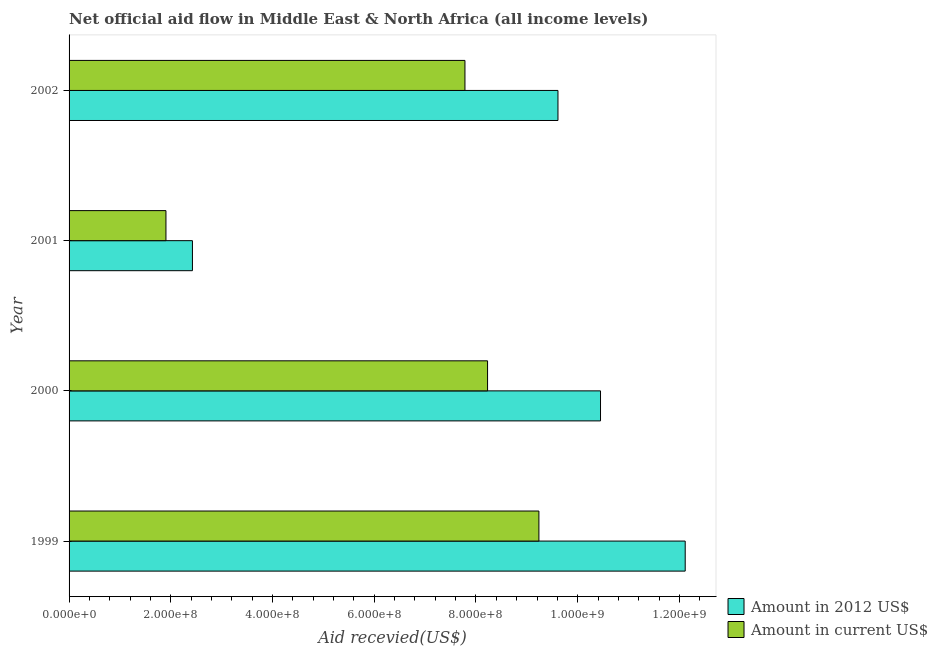Are the number of bars per tick equal to the number of legend labels?
Give a very brief answer. Yes. Are the number of bars on each tick of the Y-axis equal?
Provide a short and direct response. Yes. How many bars are there on the 2nd tick from the bottom?
Your response must be concise. 2. What is the label of the 4th group of bars from the top?
Provide a short and direct response. 1999. What is the amount of aid received(expressed in us$) in 2000?
Your response must be concise. 8.23e+08. Across all years, what is the maximum amount of aid received(expressed in 2012 us$)?
Make the answer very short. 1.21e+09. Across all years, what is the minimum amount of aid received(expressed in 2012 us$)?
Your answer should be compact. 2.43e+08. In which year was the amount of aid received(expressed in 2012 us$) minimum?
Keep it short and to the point. 2001. What is the total amount of aid received(expressed in us$) in the graph?
Your response must be concise. 2.72e+09. What is the difference between the amount of aid received(expressed in 2012 us$) in 1999 and that in 2001?
Ensure brevity in your answer.  9.69e+08. What is the difference between the amount of aid received(expressed in 2012 us$) in 2000 and the amount of aid received(expressed in us$) in 1999?
Your answer should be compact. 1.21e+08. What is the average amount of aid received(expressed in 2012 us$) per year?
Make the answer very short. 8.65e+08. In the year 2001, what is the difference between the amount of aid received(expressed in 2012 us$) and amount of aid received(expressed in us$)?
Offer a terse response. 5.21e+07. What is the ratio of the amount of aid received(expressed in us$) in 1999 to that in 2001?
Offer a very short reply. 4.85. Is the difference between the amount of aid received(expressed in us$) in 2000 and 2002 greater than the difference between the amount of aid received(expressed in 2012 us$) in 2000 and 2002?
Keep it short and to the point. No. What is the difference between the highest and the second highest amount of aid received(expressed in us$)?
Provide a short and direct response. 1.01e+08. What is the difference between the highest and the lowest amount of aid received(expressed in 2012 us$)?
Give a very brief answer. 9.69e+08. In how many years, is the amount of aid received(expressed in us$) greater than the average amount of aid received(expressed in us$) taken over all years?
Your response must be concise. 3. Is the sum of the amount of aid received(expressed in 2012 us$) in 1999 and 2000 greater than the maximum amount of aid received(expressed in us$) across all years?
Provide a succinct answer. Yes. What does the 2nd bar from the top in 2001 represents?
Give a very brief answer. Amount in 2012 US$. What does the 2nd bar from the bottom in 1999 represents?
Give a very brief answer. Amount in current US$. Are all the bars in the graph horizontal?
Offer a very short reply. Yes. How many years are there in the graph?
Your answer should be compact. 4. Does the graph contain grids?
Offer a terse response. No. Where does the legend appear in the graph?
Give a very brief answer. Bottom right. How many legend labels are there?
Offer a very short reply. 2. What is the title of the graph?
Give a very brief answer. Net official aid flow in Middle East & North Africa (all income levels). What is the label or title of the X-axis?
Your response must be concise. Aid recevied(US$). What is the label or title of the Y-axis?
Ensure brevity in your answer.  Year. What is the Aid recevied(US$) of Amount in 2012 US$ in 1999?
Your answer should be very brief. 1.21e+09. What is the Aid recevied(US$) of Amount in current US$ in 1999?
Make the answer very short. 9.24e+08. What is the Aid recevied(US$) of Amount in 2012 US$ in 2000?
Provide a short and direct response. 1.04e+09. What is the Aid recevied(US$) in Amount in current US$ in 2000?
Your response must be concise. 8.23e+08. What is the Aid recevied(US$) in Amount in 2012 US$ in 2001?
Offer a very short reply. 2.43e+08. What is the Aid recevied(US$) of Amount in current US$ in 2001?
Your answer should be compact. 1.90e+08. What is the Aid recevied(US$) in Amount in 2012 US$ in 2002?
Ensure brevity in your answer.  9.61e+08. What is the Aid recevied(US$) of Amount in current US$ in 2002?
Offer a terse response. 7.78e+08. Across all years, what is the maximum Aid recevied(US$) in Amount in 2012 US$?
Offer a terse response. 1.21e+09. Across all years, what is the maximum Aid recevied(US$) of Amount in current US$?
Your answer should be compact. 9.24e+08. Across all years, what is the minimum Aid recevied(US$) in Amount in 2012 US$?
Ensure brevity in your answer.  2.43e+08. Across all years, what is the minimum Aid recevied(US$) of Amount in current US$?
Provide a succinct answer. 1.90e+08. What is the total Aid recevied(US$) in Amount in 2012 US$ in the graph?
Ensure brevity in your answer.  3.46e+09. What is the total Aid recevied(US$) of Amount in current US$ in the graph?
Offer a terse response. 2.72e+09. What is the difference between the Aid recevied(US$) in Amount in 2012 US$ in 1999 and that in 2000?
Offer a very short reply. 1.67e+08. What is the difference between the Aid recevied(US$) of Amount in current US$ in 1999 and that in 2000?
Offer a terse response. 1.01e+08. What is the difference between the Aid recevied(US$) in Amount in 2012 US$ in 1999 and that in 2001?
Make the answer very short. 9.69e+08. What is the difference between the Aid recevied(US$) in Amount in current US$ in 1999 and that in 2001?
Ensure brevity in your answer.  7.33e+08. What is the difference between the Aid recevied(US$) in Amount in 2012 US$ in 1999 and that in 2002?
Provide a short and direct response. 2.50e+08. What is the difference between the Aid recevied(US$) in Amount in current US$ in 1999 and that in 2002?
Provide a succinct answer. 1.45e+08. What is the difference between the Aid recevied(US$) in Amount in 2012 US$ in 2000 and that in 2001?
Your answer should be compact. 8.02e+08. What is the difference between the Aid recevied(US$) in Amount in current US$ in 2000 and that in 2001?
Ensure brevity in your answer.  6.32e+08. What is the difference between the Aid recevied(US$) in Amount in 2012 US$ in 2000 and that in 2002?
Provide a short and direct response. 8.36e+07. What is the difference between the Aid recevied(US$) in Amount in current US$ in 2000 and that in 2002?
Your response must be concise. 4.45e+07. What is the difference between the Aid recevied(US$) of Amount in 2012 US$ in 2001 and that in 2002?
Make the answer very short. -7.19e+08. What is the difference between the Aid recevied(US$) of Amount in current US$ in 2001 and that in 2002?
Provide a short and direct response. -5.88e+08. What is the difference between the Aid recevied(US$) in Amount in 2012 US$ in 1999 and the Aid recevied(US$) in Amount in current US$ in 2000?
Your answer should be very brief. 3.89e+08. What is the difference between the Aid recevied(US$) of Amount in 2012 US$ in 1999 and the Aid recevied(US$) of Amount in current US$ in 2001?
Keep it short and to the point. 1.02e+09. What is the difference between the Aid recevied(US$) of Amount in 2012 US$ in 1999 and the Aid recevied(US$) of Amount in current US$ in 2002?
Provide a succinct answer. 4.33e+08. What is the difference between the Aid recevied(US$) of Amount in 2012 US$ in 2000 and the Aid recevied(US$) of Amount in current US$ in 2001?
Offer a very short reply. 8.54e+08. What is the difference between the Aid recevied(US$) in Amount in 2012 US$ in 2000 and the Aid recevied(US$) in Amount in current US$ in 2002?
Keep it short and to the point. 2.67e+08. What is the difference between the Aid recevied(US$) of Amount in 2012 US$ in 2001 and the Aid recevied(US$) of Amount in current US$ in 2002?
Your answer should be very brief. -5.36e+08. What is the average Aid recevied(US$) in Amount in 2012 US$ per year?
Offer a very short reply. 8.65e+08. What is the average Aid recevied(US$) of Amount in current US$ per year?
Offer a terse response. 6.79e+08. In the year 1999, what is the difference between the Aid recevied(US$) of Amount in 2012 US$ and Aid recevied(US$) of Amount in current US$?
Your answer should be compact. 2.88e+08. In the year 2000, what is the difference between the Aid recevied(US$) of Amount in 2012 US$ and Aid recevied(US$) of Amount in current US$?
Your response must be concise. 2.22e+08. In the year 2001, what is the difference between the Aid recevied(US$) in Amount in 2012 US$ and Aid recevied(US$) in Amount in current US$?
Provide a succinct answer. 5.21e+07. In the year 2002, what is the difference between the Aid recevied(US$) in Amount in 2012 US$ and Aid recevied(US$) in Amount in current US$?
Offer a terse response. 1.83e+08. What is the ratio of the Aid recevied(US$) of Amount in 2012 US$ in 1999 to that in 2000?
Keep it short and to the point. 1.16. What is the ratio of the Aid recevied(US$) of Amount in current US$ in 1999 to that in 2000?
Give a very brief answer. 1.12. What is the ratio of the Aid recevied(US$) in Amount in 2012 US$ in 1999 to that in 2001?
Ensure brevity in your answer.  4.99. What is the ratio of the Aid recevied(US$) of Amount in current US$ in 1999 to that in 2001?
Offer a very short reply. 4.85. What is the ratio of the Aid recevied(US$) in Amount in 2012 US$ in 1999 to that in 2002?
Offer a terse response. 1.26. What is the ratio of the Aid recevied(US$) of Amount in current US$ in 1999 to that in 2002?
Provide a succinct answer. 1.19. What is the ratio of the Aid recevied(US$) of Amount in 2012 US$ in 2000 to that in 2001?
Offer a very short reply. 4.31. What is the ratio of the Aid recevied(US$) in Amount in current US$ in 2000 to that in 2001?
Your answer should be compact. 4.32. What is the ratio of the Aid recevied(US$) of Amount in 2012 US$ in 2000 to that in 2002?
Give a very brief answer. 1.09. What is the ratio of the Aid recevied(US$) of Amount in current US$ in 2000 to that in 2002?
Offer a terse response. 1.06. What is the ratio of the Aid recevied(US$) in Amount in 2012 US$ in 2001 to that in 2002?
Give a very brief answer. 0.25. What is the ratio of the Aid recevied(US$) of Amount in current US$ in 2001 to that in 2002?
Make the answer very short. 0.24. What is the difference between the highest and the second highest Aid recevied(US$) of Amount in 2012 US$?
Offer a very short reply. 1.67e+08. What is the difference between the highest and the second highest Aid recevied(US$) in Amount in current US$?
Keep it short and to the point. 1.01e+08. What is the difference between the highest and the lowest Aid recevied(US$) in Amount in 2012 US$?
Ensure brevity in your answer.  9.69e+08. What is the difference between the highest and the lowest Aid recevied(US$) of Amount in current US$?
Ensure brevity in your answer.  7.33e+08. 